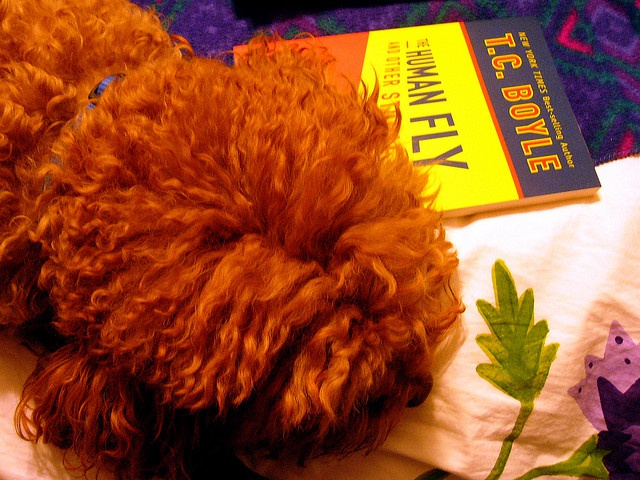Describe the objects in this image and their specific colors. I can see dog in maroon, red, and black tones, bed in maroon, white, black, navy, and tan tones, and book in maroon, yellow, purple, red, and orange tones in this image. 